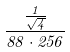Convert formula to latex. <formula><loc_0><loc_0><loc_500><loc_500>\frac { \frac { 1 } { \sqrt { 4 } } } { 8 8 \cdot 2 5 6 }</formula> 